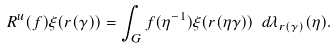<formula> <loc_0><loc_0><loc_500><loc_500>R ^ { u } ( f ) \xi ( r ( \gamma ) ) = \int _ { G } f ( \eta ^ { - 1 } ) \xi ( r ( \eta \gamma ) ) \ d \lambda _ { r ( \gamma ) } ( \eta ) .</formula> 